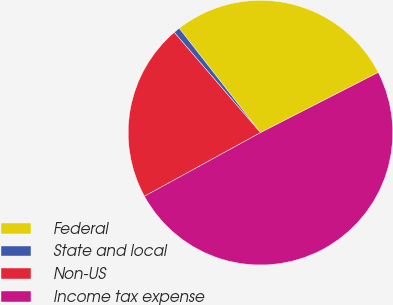<chart> <loc_0><loc_0><loc_500><loc_500><pie_chart><fcel>Federal<fcel>State and local<fcel>Non-US<fcel>Income tax expense<nl><fcel>28.0%<fcel>0.78%<fcel>21.68%<fcel>49.54%<nl></chart> 